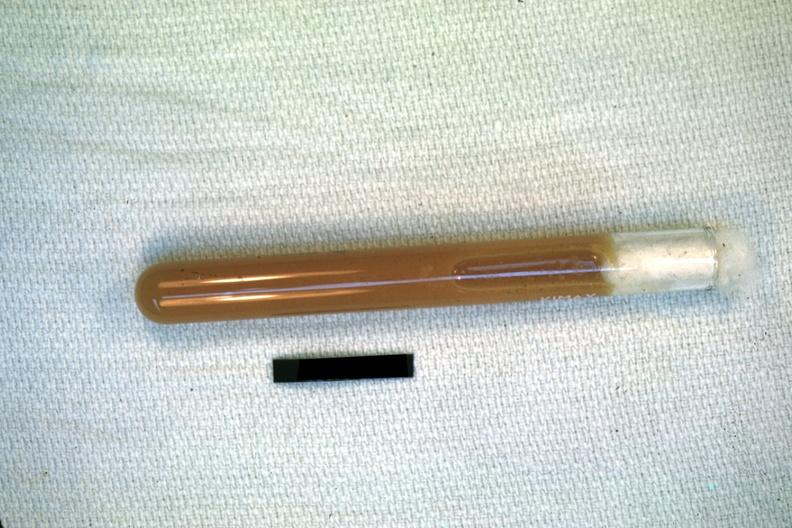does case of peritonitis slide illustrate pus from the peritoneal cavity?
Answer the question using a single word or phrase. Yes 